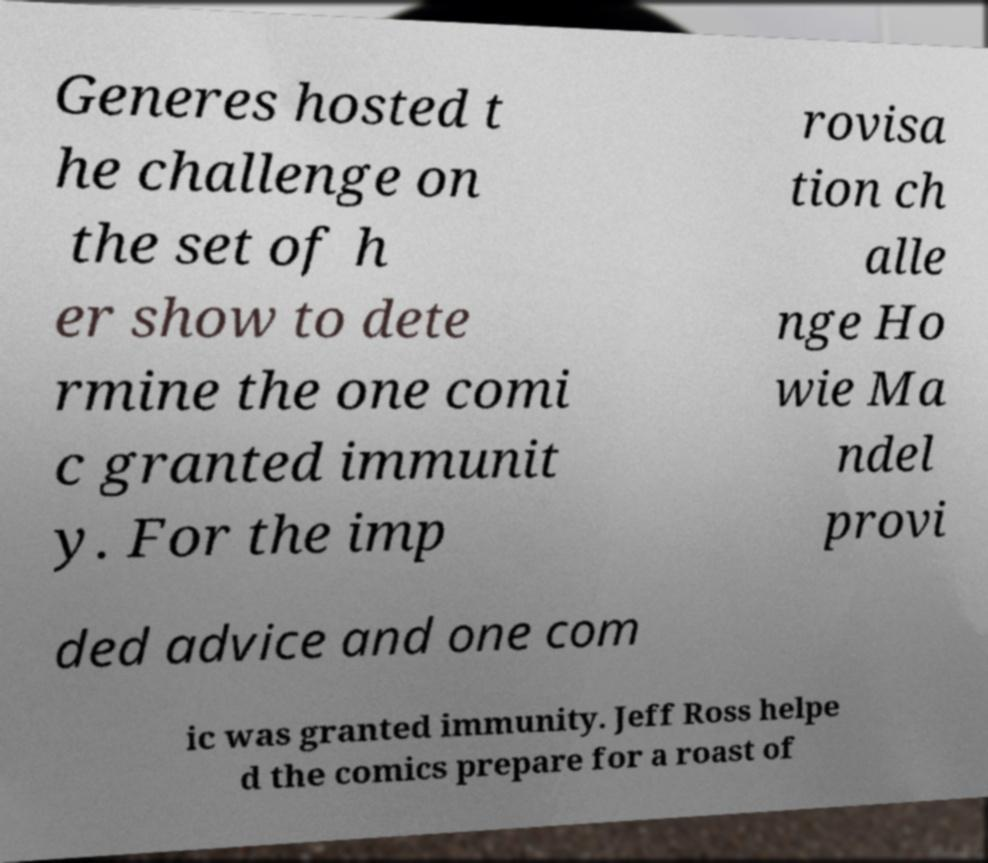Can you read and provide the text displayed in the image?This photo seems to have some interesting text. Can you extract and type it out for me? Generes hosted t he challenge on the set of h er show to dete rmine the one comi c granted immunit y. For the imp rovisa tion ch alle nge Ho wie Ma ndel provi ded advice and one com ic was granted immunity. Jeff Ross helpe d the comics prepare for a roast of 